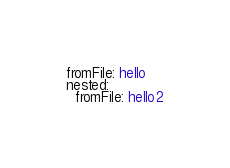<code> <loc_0><loc_0><loc_500><loc_500><_YAML_>fromFile: hello
nested:
  fromFile: hello2</code> 